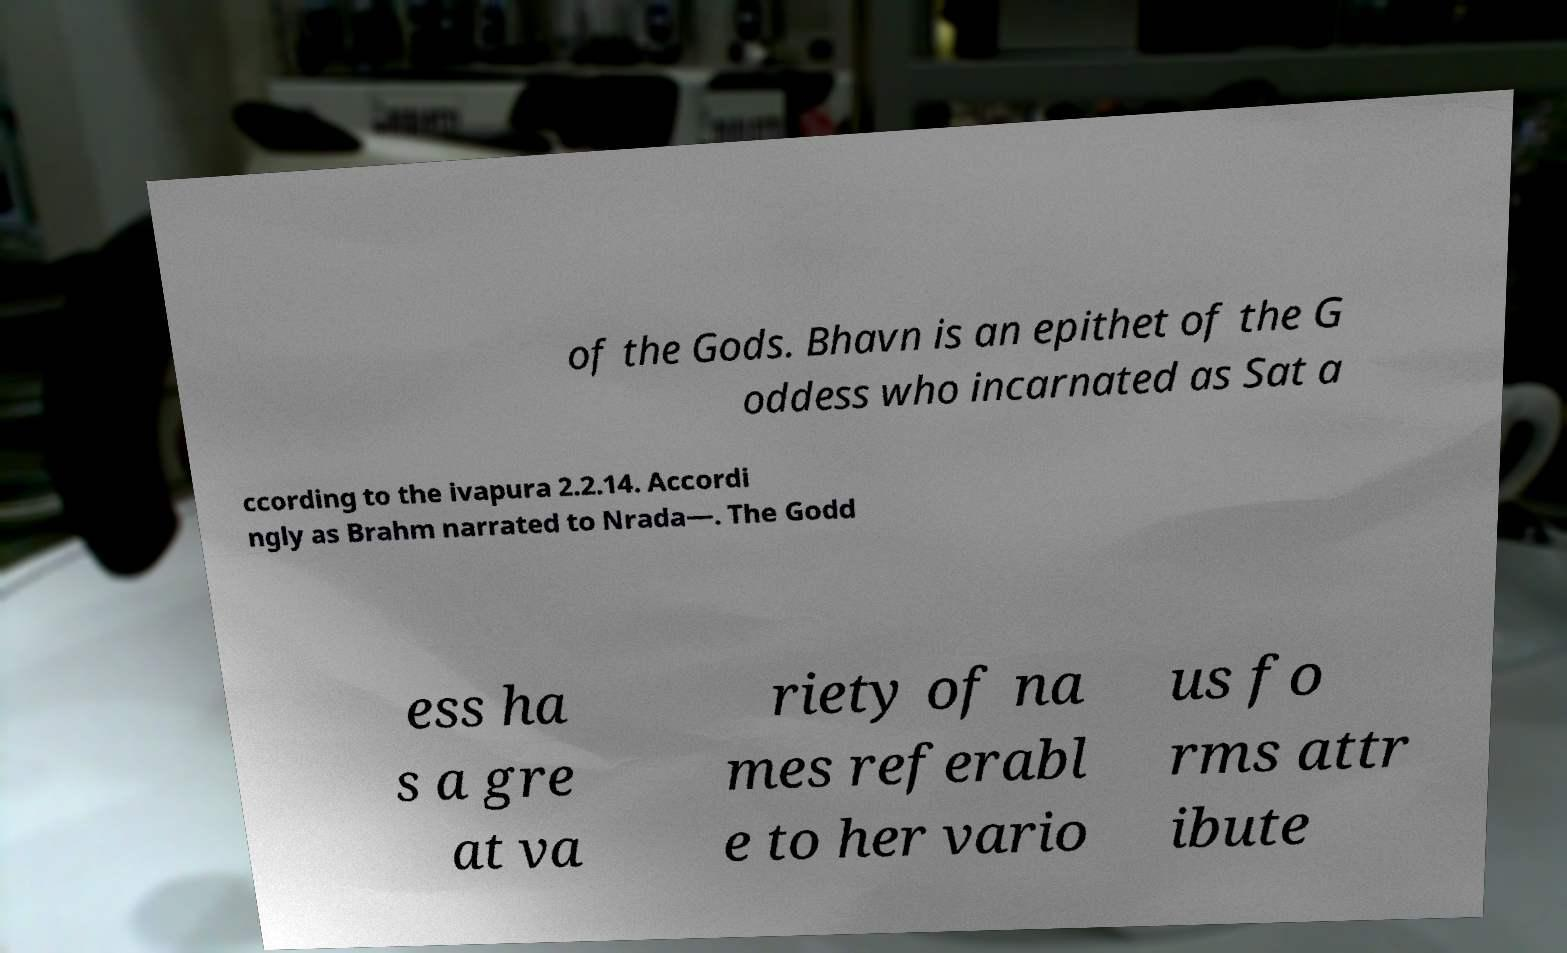Please read and relay the text visible in this image. What does it say? of the Gods. Bhavn is an epithet of the G oddess who incarnated as Sat a ccording to the ivapura 2.2.14. Accordi ngly as Brahm narrated to Nrada—. The Godd ess ha s a gre at va riety of na mes referabl e to her vario us fo rms attr ibute 